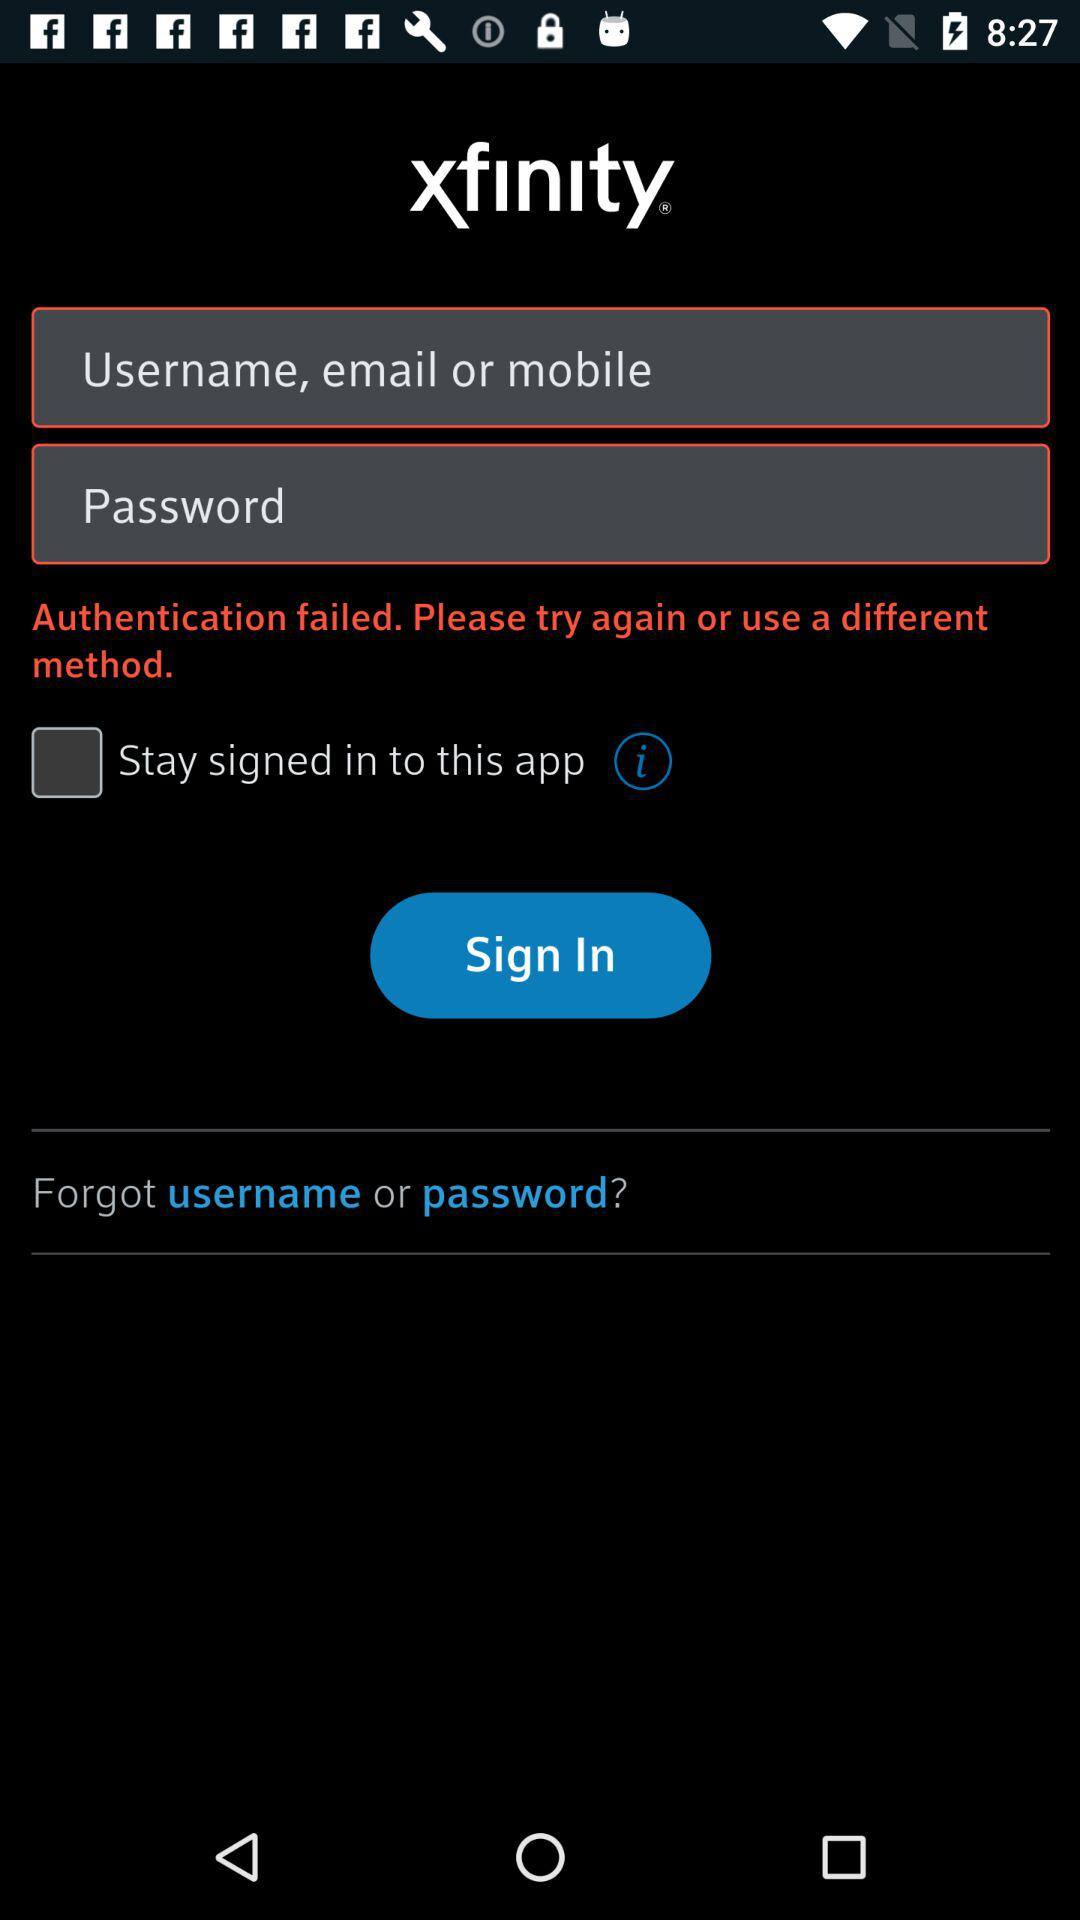Can we reset username?
When the provided information is insufficient, respond with <no answer>. <no answer> 